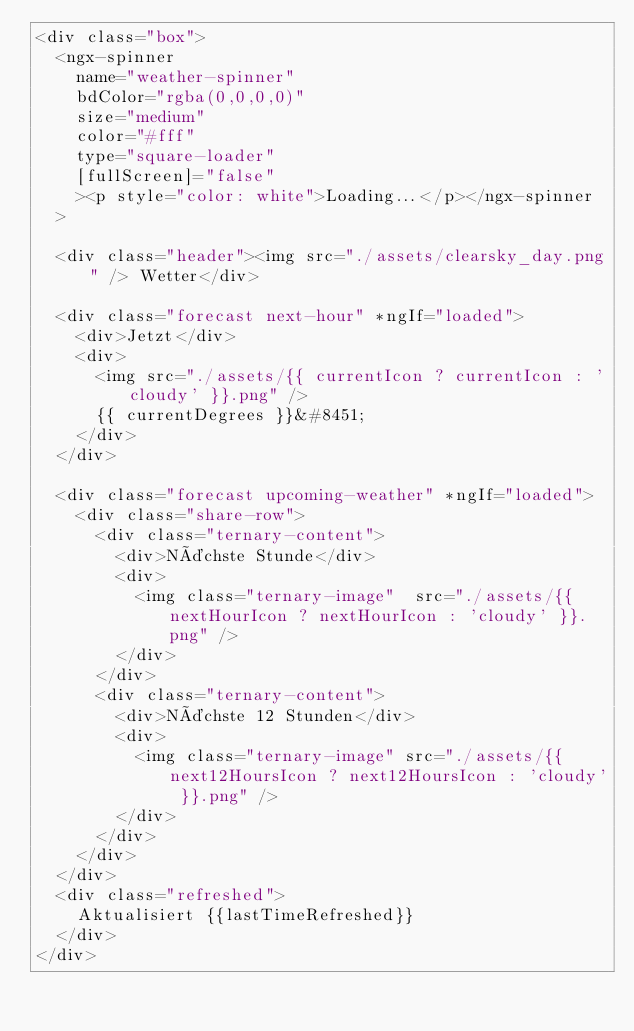Convert code to text. <code><loc_0><loc_0><loc_500><loc_500><_HTML_><div class="box">
  <ngx-spinner
    name="weather-spinner"
    bdColor="rgba(0,0,0,0)"
    size="medium"
    color="#fff"
    type="square-loader"
    [fullScreen]="false"
    ><p style="color: white">Loading...</p></ngx-spinner
  >

  <div class="header"><img src="./assets/clearsky_day.png" /> Wetter</div>

  <div class="forecast next-hour" *ngIf="loaded">
    <div>Jetzt</div>
    <div>
      <img src="./assets/{{ currentIcon ? currentIcon : 'cloudy' }}.png" />
      {{ currentDegrees }}&#8451;
    </div>
  </div>

  <div class="forecast upcoming-weather" *ngIf="loaded">
    <div class="share-row">
      <div class="ternary-content">
        <div>Nächste Stunde</div>
        <div>
          <img class="ternary-image"  src="./assets/{{ nextHourIcon ? nextHourIcon : 'cloudy' }}.png" />
        </div>
      </div>
      <div class="ternary-content">
        <div>Nächste 12 Stunden</div>
        <div>
          <img class="ternary-image" src="./assets/{{ next12HoursIcon ? next12HoursIcon : 'cloudy' }}.png" />
        </div>
      </div>
    </div>
  </div>
  <div class="refreshed">
    Aktualisiert {{lastTimeRefreshed}}
  </div>
</div>
</code> 